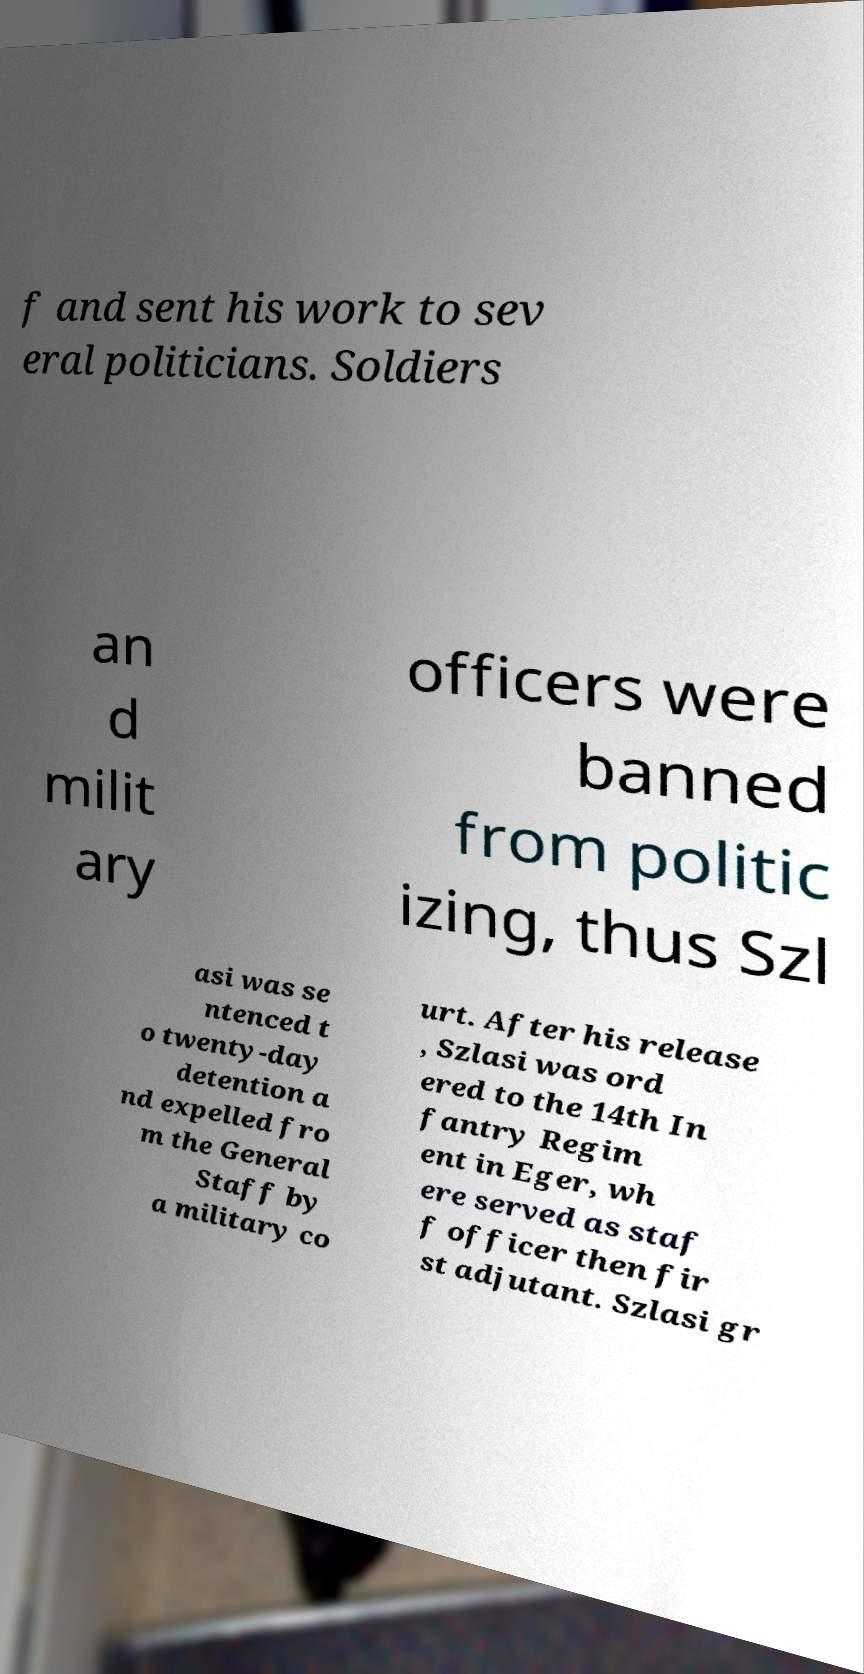What messages or text are displayed in this image? I need them in a readable, typed format. f and sent his work to sev eral politicians. Soldiers an d milit ary officers were banned from politic izing, thus Szl asi was se ntenced t o twenty-day detention a nd expelled fro m the General Staff by a military co urt. After his release , Szlasi was ord ered to the 14th In fantry Regim ent in Eger, wh ere served as staf f officer then fir st adjutant. Szlasi gr 